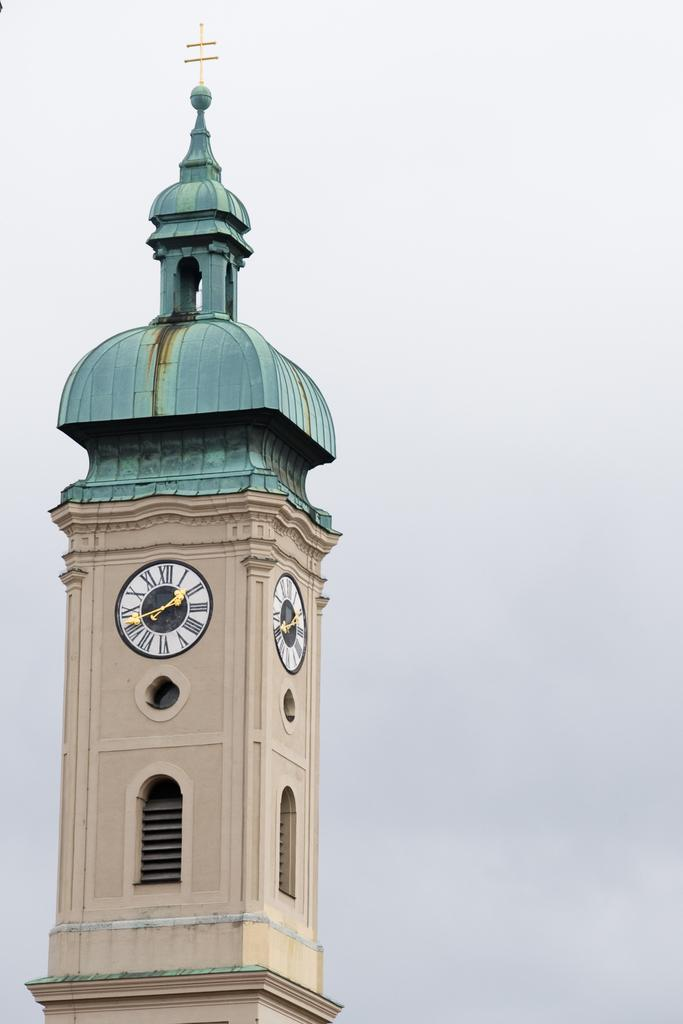What is the main structure in the picture? There is a tower in the picture. What feature is present on the tower? The tower has clocks on it. What can be seen in the background of the picture? The sky is visible in the background of the picture. Can you see a basket being used for running in the picture? There is no basket or running depicted in the image; it features a tower with clocks and a visible sky. 